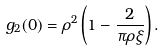<formula> <loc_0><loc_0><loc_500><loc_500>g _ { 2 } ( 0 ) = \rho ^ { 2 } \left ( 1 - \frac { 2 } { \pi \rho \xi } \right ) .</formula> 